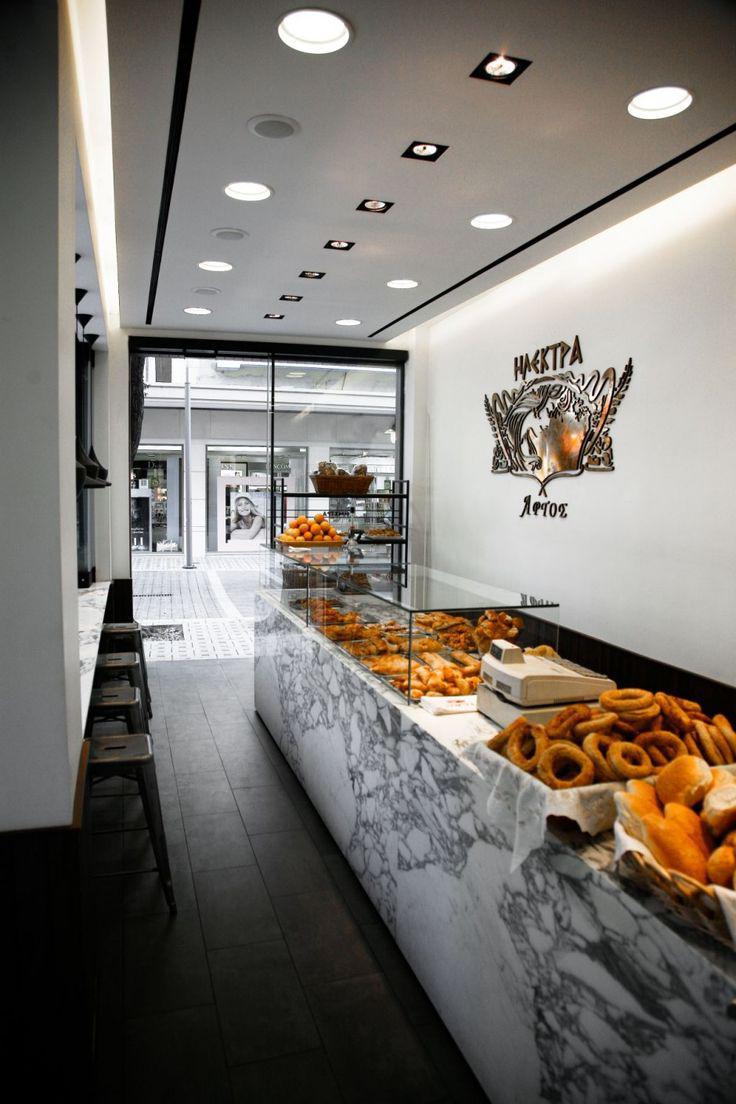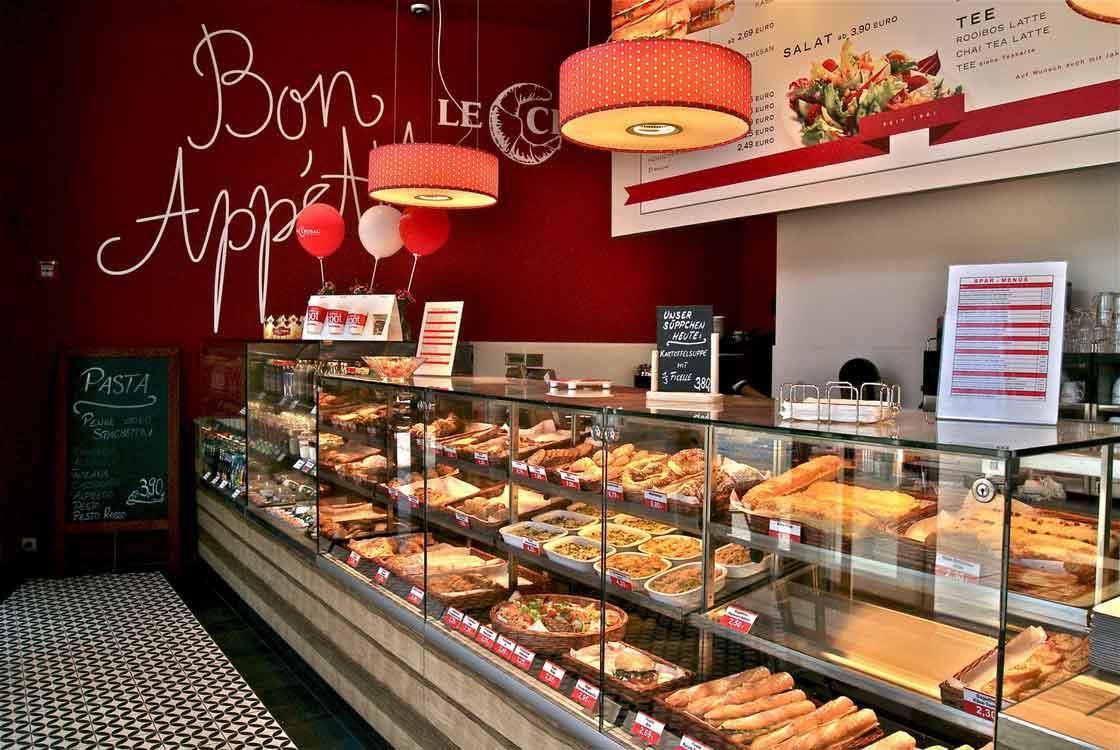The first image is the image on the left, the second image is the image on the right. Assess this claim about the two images: "The right image contains at least 2 pendant style lamps above the bakery case.". Correct or not? Answer yes or no. Yes. The first image is the image on the left, the second image is the image on the right. Given the left and right images, does the statement "In at least one image you can see a dropped or lowered all white hood lamp near the bakery." hold true? Answer yes or no. No. 